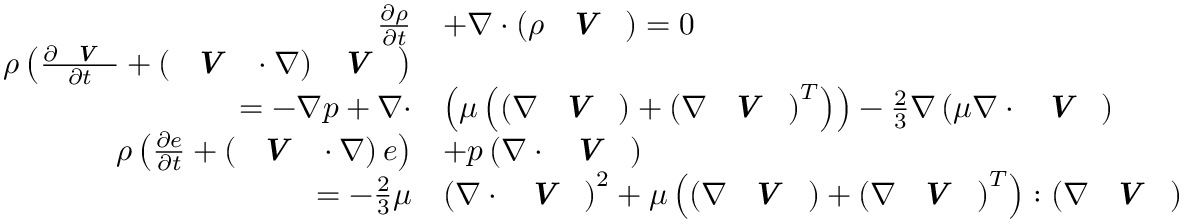<formula> <loc_0><loc_0><loc_500><loc_500>\begin{array} { r l } { \frac { \partial \rho } { \partial t } } & { + \nabla \cdot \left ( \rho V \right ) = 0 } \\ { \rho \left ( \frac { \partial V } { \partial t } + \left ( V \cdot \nabla \right ) V \right ) } \\ { = - \nabla p + \nabla \cdot } & { \left ( \mu \left ( \left ( \nabla V \right ) + \left ( \nabla V \right ) ^ { T } \right ) \right ) - \frac { 2 } { 3 } \nabla \left ( \mu \nabla \cdot V \right ) } \\ { \rho \left ( \frac { \partial e } { \partial t } + \left ( V \cdot \nabla \right ) e \right ) } & { + p \left ( \nabla \cdot V \right ) } \\ { = - \frac { 2 } { 3 } \mu } & { \left ( \nabla \cdot V \right ) ^ { 2 } + \mu \left ( \left ( \nabla V \right ) + \left ( \nabla V \right ) ^ { T } \right ) \colon \left ( \nabla V \right ) } \end{array}</formula> 